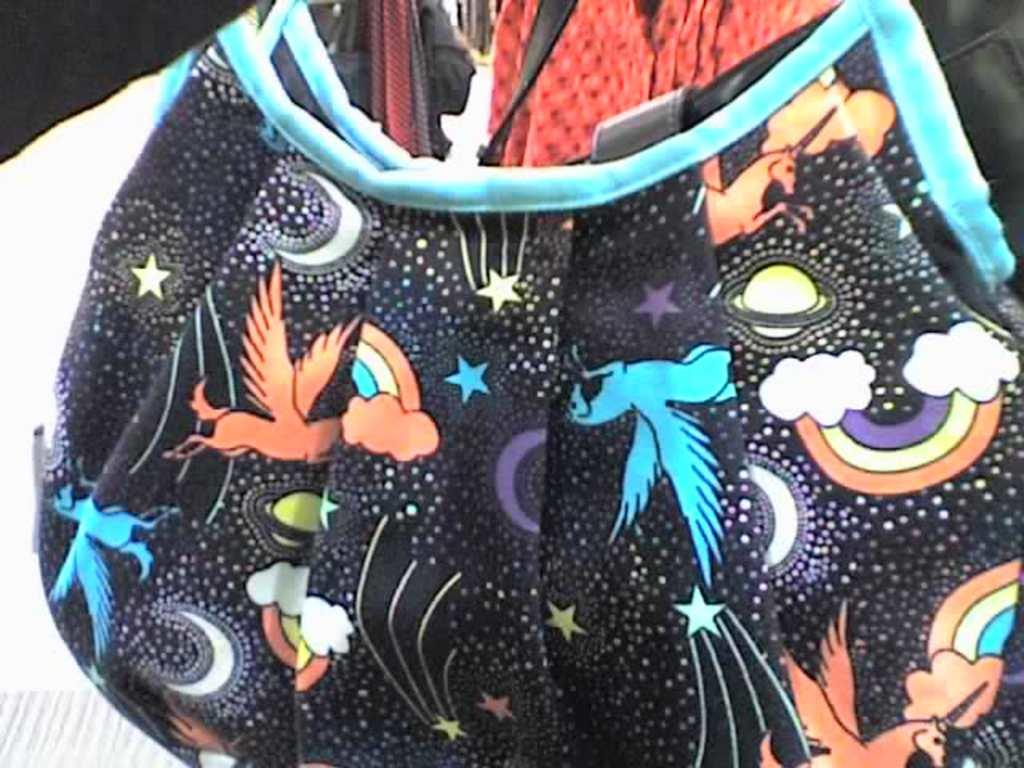What object is present in the image? There is a bag in the image. Can you describe the color of the bag? The bag is black in color. How does the bag use a spade in the image? There is no spade present in the image, and therefore no such interaction can be observed. 